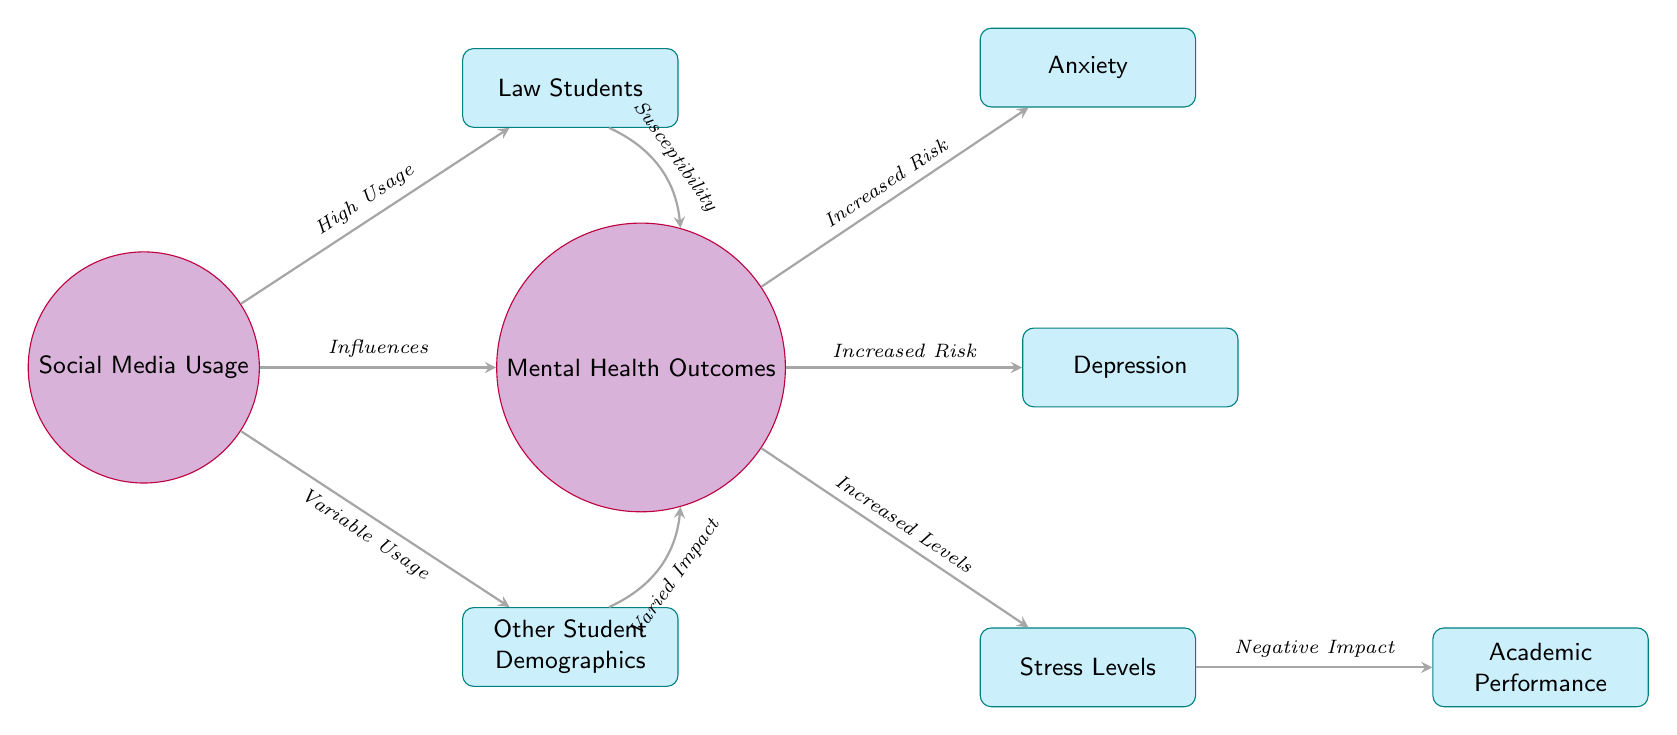What's the central theme of the diagram? The diagram illustrates the relationship between social media usage and mental health outcomes specifically among law students compared to other student demographics. This thematic focus is indicated by the primary node titled "Social Media Usage" and the corresponding outcomes linked to it.
Answer: The impact of social media usage on mental health How many main demographic groups are represented in the diagram? There are two main demographic groups represented in the diagram: "Law Students" and "Other Student Demographics," which are connected to the central theme of social media usage.
Answer: Two Which outcome is linked to the law students' susceptibility? The outcome linked to law students' susceptibility is "Mental Health Outcomes." This relationship is shown with a bent arrow pointing from "Law Students" to "Mental Health Outcomes," indicating their specific risk associated with social media usage.
Answer: Mental Health Outcomes What type of relationship exists between social media usage and mental health outcomes? The diagram indicates a causal relationship, where social media usage influences mental health outcomes. The word "Influences" is present on the arrow connecting the two nodes, demonstrating this effect.
Answer: Influences What specific mental health issues are identified in the diagram? The diagram identifies three specific mental health issues: "Anxiety," "Depression," and "Stress Levels." Each is depicted as an outcome stemming from the central node of "Mental Health Outcomes."
Answer: Anxiety, Depression, Stress Levels How does stress level affect academic performance? The diagram shows that increased stress levels have a negative impact on academic performance. This relationship is depicted through an arrow labeled "Negative Impact" from the "Stress Levels" node to the "Academic Performance" node.
Answer: Negative Impact Which student group is shown to have high usage of social media? The diagram indicates that "Law Students" are depicted as having high usage of social media, as shown by the phrase "High Usage" on the arrow directed toward the "Law Students" node from "Social Media Usage."
Answer: Law Students What does "Varied Impact" signify for other student demographics? "Varied Impact" signifies that the relationship between social media usage and mental health outcomes differs in magnitude or nature among other student demographics. It is illustrated by an arrow that connects the "Other Student Demographics" to "Mental Health Outcomes."
Answer: Varied Impact 